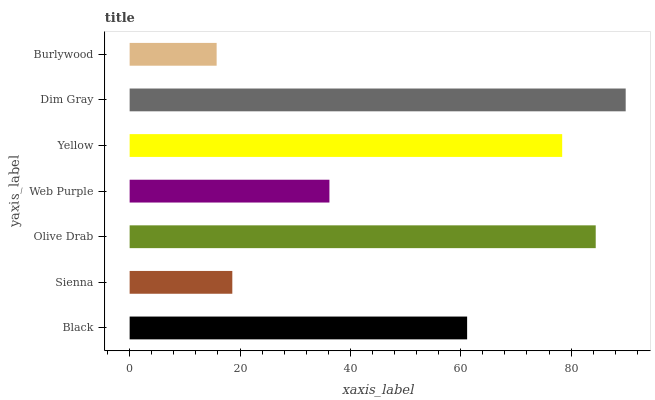Is Burlywood the minimum?
Answer yes or no. Yes. Is Dim Gray the maximum?
Answer yes or no. Yes. Is Sienna the minimum?
Answer yes or no. No. Is Sienna the maximum?
Answer yes or no. No. Is Black greater than Sienna?
Answer yes or no. Yes. Is Sienna less than Black?
Answer yes or no. Yes. Is Sienna greater than Black?
Answer yes or no. No. Is Black less than Sienna?
Answer yes or no. No. Is Black the high median?
Answer yes or no. Yes. Is Black the low median?
Answer yes or no. Yes. Is Web Purple the high median?
Answer yes or no. No. Is Web Purple the low median?
Answer yes or no. No. 